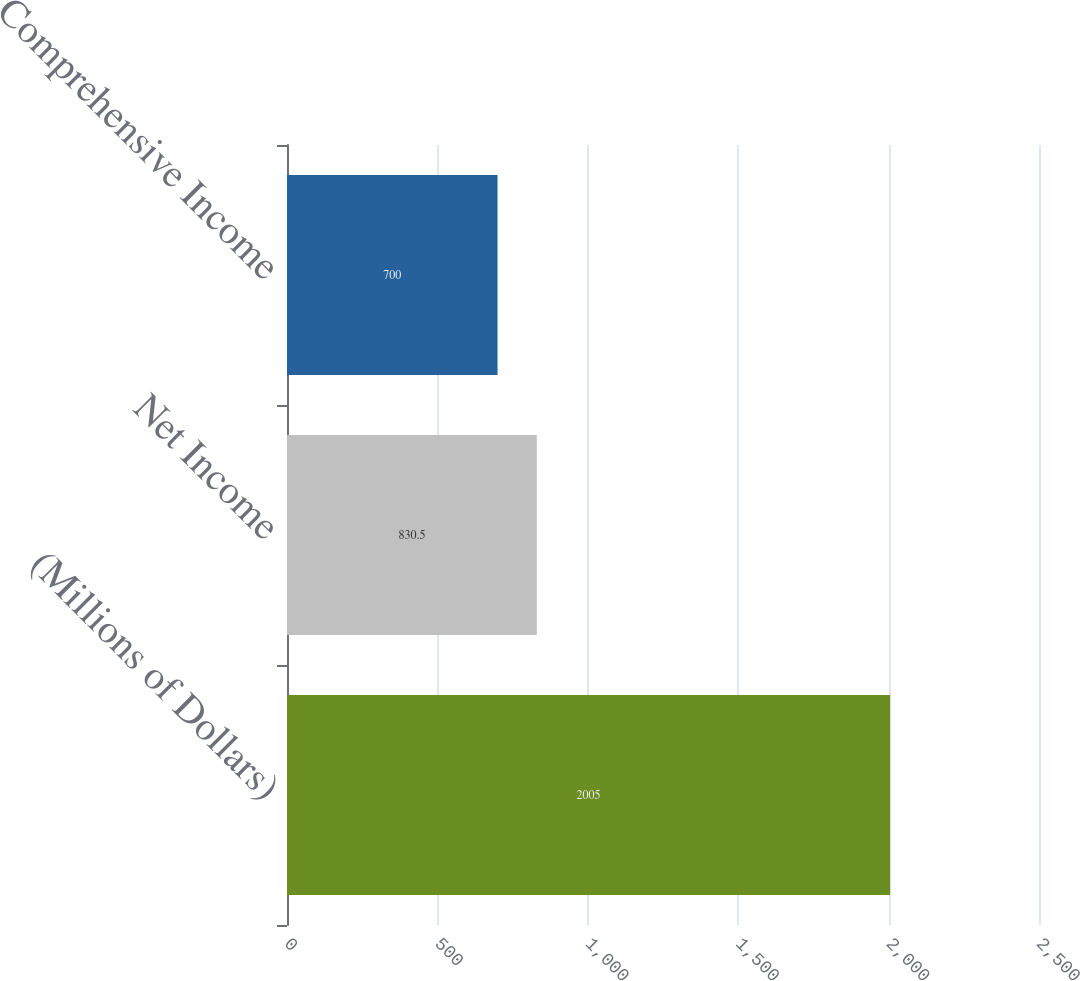<chart> <loc_0><loc_0><loc_500><loc_500><bar_chart><fcel>(Millions of Dollars)<fcel>Net Income<fcel>Comprehensive Income<nl><fcel>2005<fcel>830.5<fcel>700<nl></chart> 